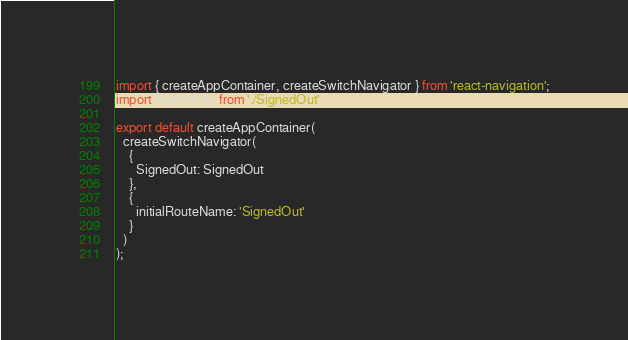Convert code to text. <code><loc_0><loc_0><loc_500><loc_500><_JavaScript_>import { createAppContainer, createSwitchNavigator } from 'react-navigation';
import SignedOut from './SignedOut';

export default createAppContainer(
  createSwitchNavigator(
    {
      SignedOut: SignedOut
    },
    {
      initialRouteName: 'SignedOut'
    }
  )
);
</code> 